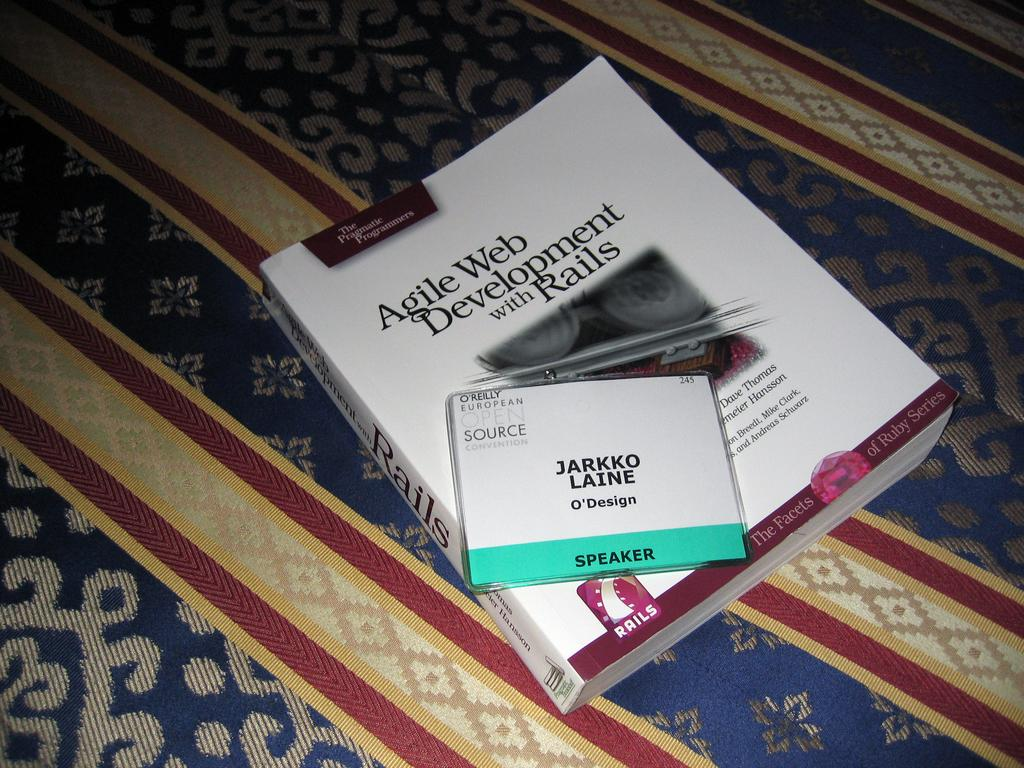<image>
Offer a succinct explanation of the picture presented. In the book you can read about Agile Web Development with Rails. 